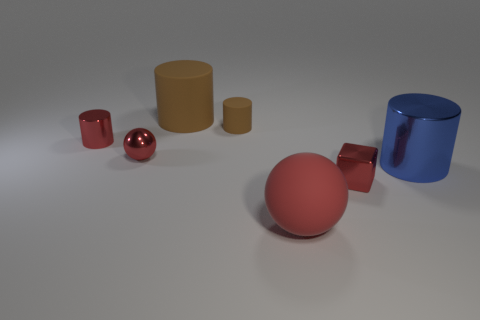Add 2 big cylinders. How many objects exist? 9 Subtract all cylinders. How many objects are left? 3 Subtract all red rubber objects. Subtract all big rubber balls. How many objects are left? 5 Add 5 red balls. How many red balls are left? 7 Add 3 big brown matte things. How many big brown matte things exist? 4 Subtract 0 yellow spheres. How many objects are left? 7 